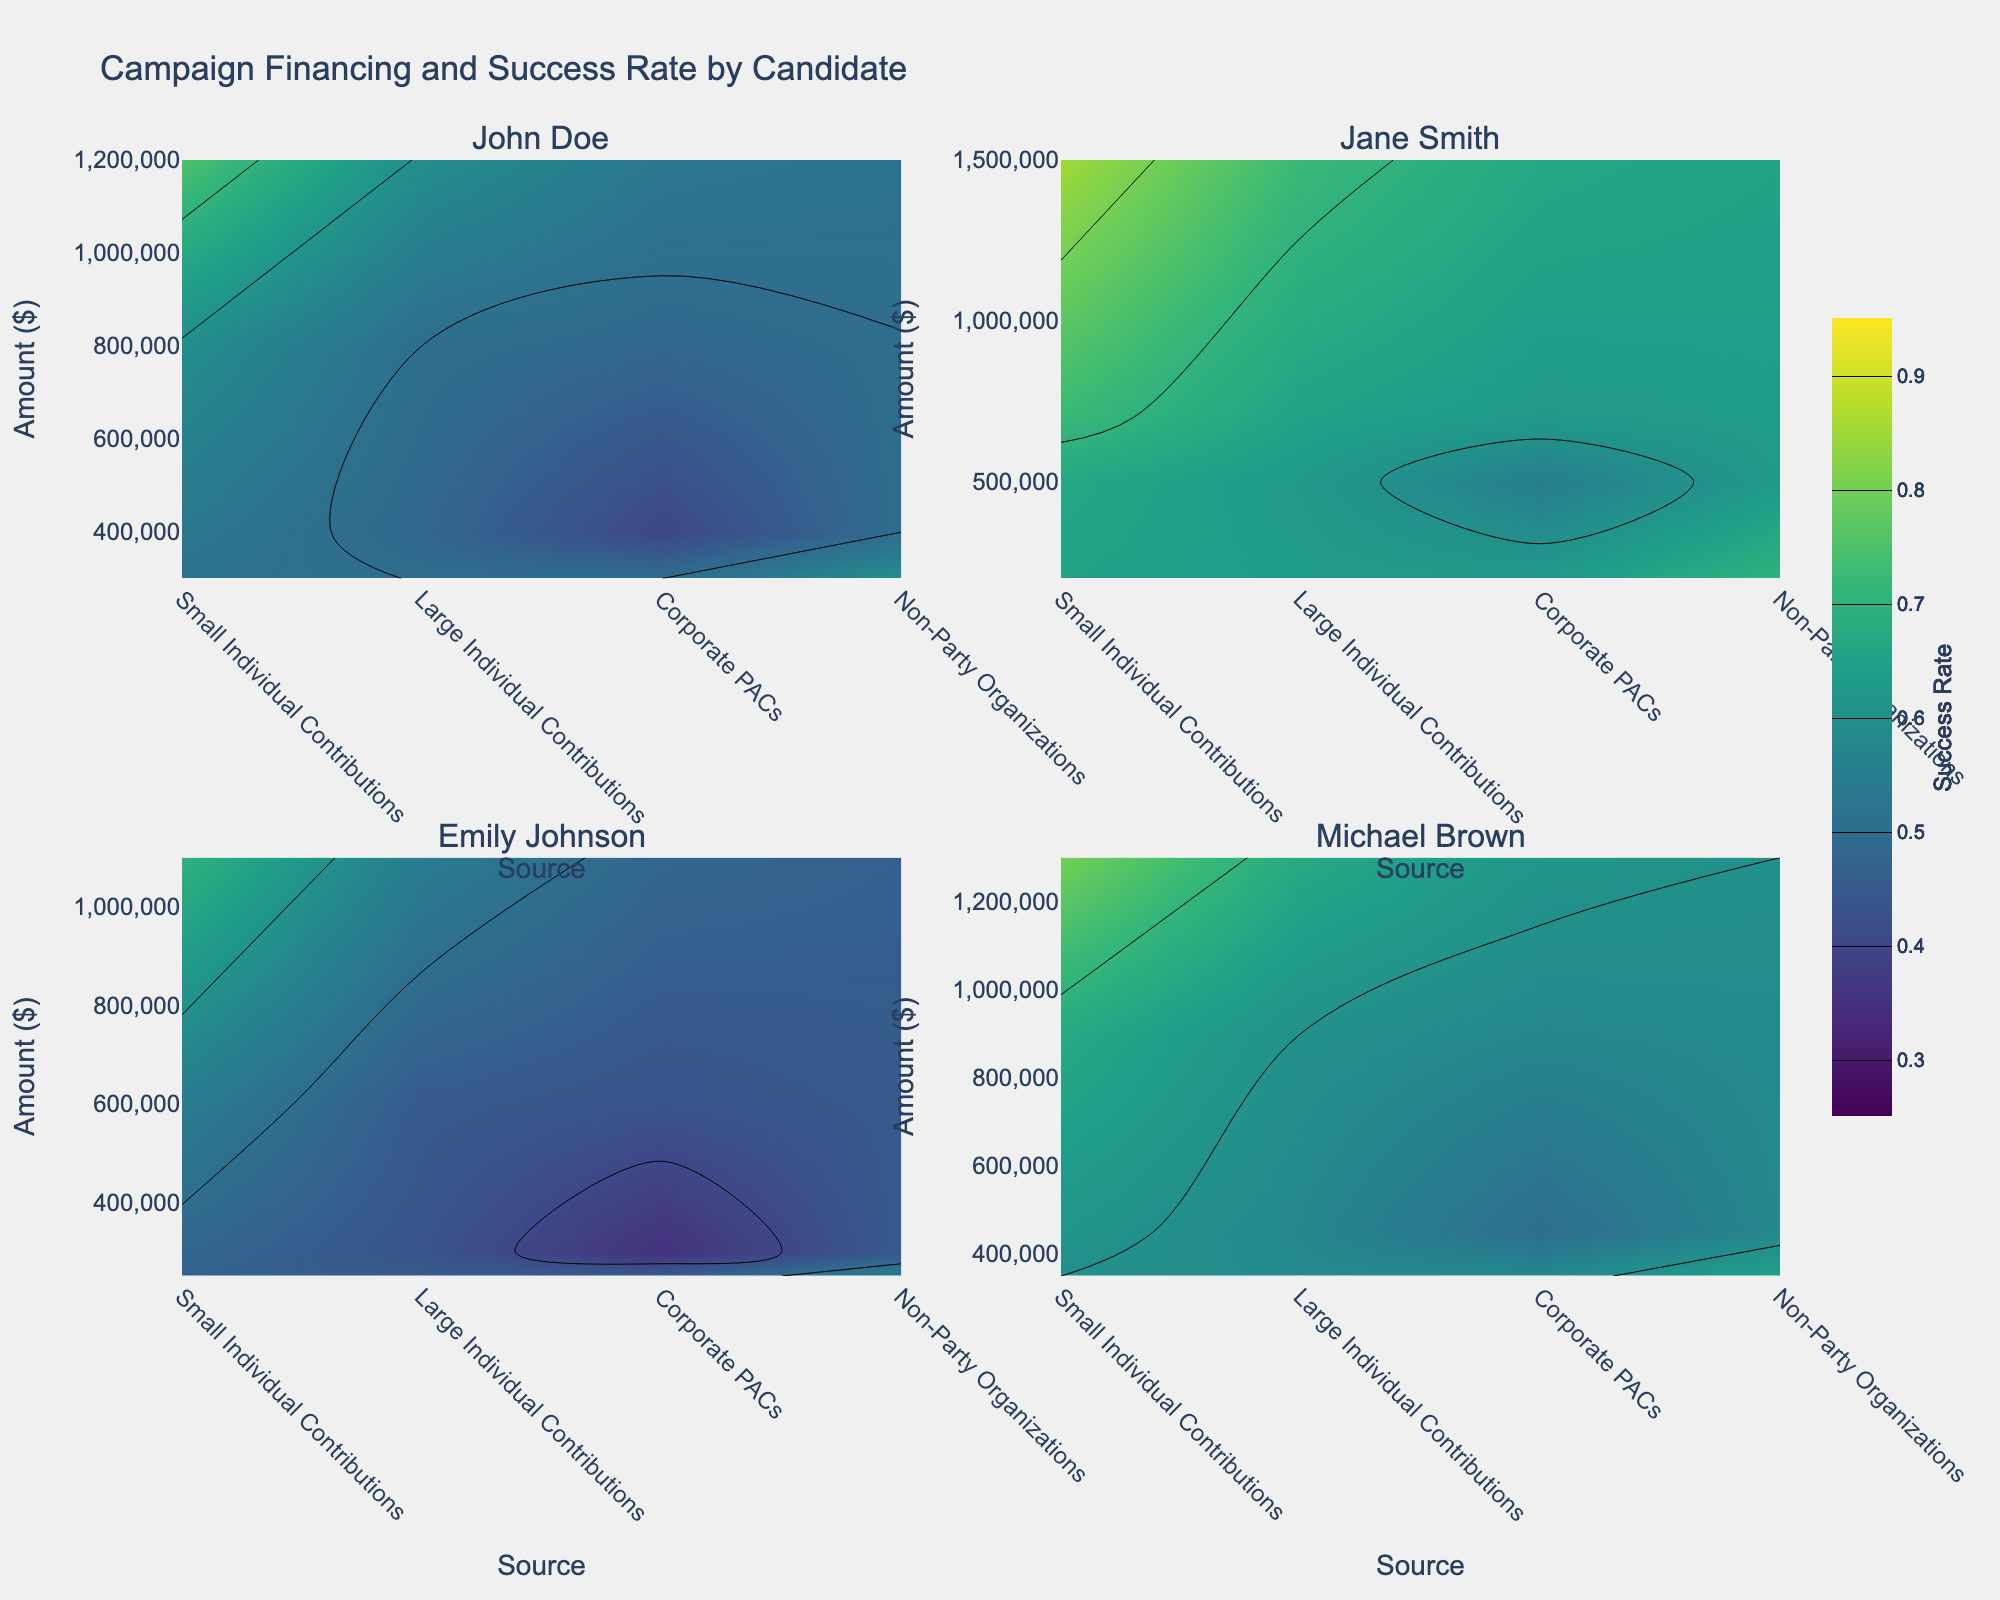What is the title of the figure? The title is usually displayed at the top of the figure. In this case, the title is "Campaign Financing and Success Rate by Candidate," as specified in the code.
Answer: Campaign Financing and Success Rate by Candidate Which candidate has the highest success rate for Small Individual Contributions? By examining the contours for Small Individual Contributions across all candidates, we see that Jane Smith has the highest success rate at 0.85.
Answer: Jane Smith For John Doe, how does the success rate vary with the amount of Large Individual Contributions? Referring to John Doe's subplot, we notice that the success rate increases from 0.5 as we examine higher amounts of Large Individual Contributions. This can be found by following the contour lines with increasing financial contributions.
Answer: increases What is the average success rate for Michael Brown across all sources of campaign financing? For Michael Brown, identify the success rates from the contours for all sources (0.8, 0.6, 0.5, 0.65). Sum them up and divide by the number of sources: (0.8 + 0.6 + 0.5 + 0.65) / 4 = 2.55 / 4 = 0.6375.
Answer: 0.64 Which source of campaign financing generally shows the lowest success rates among all candidates? By examining the contour plots for all candidates, Corporate PACs generally exhibit lower success rates across the candidates.
Answer: Corporate PACs Compare the success rates of Non-Party Organizations for Emily Johnson and John Doe. Who performs better? For Non-Party Organizations, Emily Johnson has a success rate of 0.55, while John Doe has a success rate of 0.6, as shown in their respective subplots. Hence, John Doe performs better.
Answer: John Doe Among the candidates, who has the most consistent success rate across different sources of campaign financing? Jane Smith has a relatively consistent success rate across various sources, ranging from 0.55 to 0.85. This can be inferred by observing the distribution of her contours.
Answer: Jane Smith What is the relationship between the amount of Small Individual Contributions and success rate for John Doe? For John Doe, increasing amounts of Small Individual Contributions correlate with higher success rates, as we follow the contour lines towards higher contributions.
Answer: positive correlation 